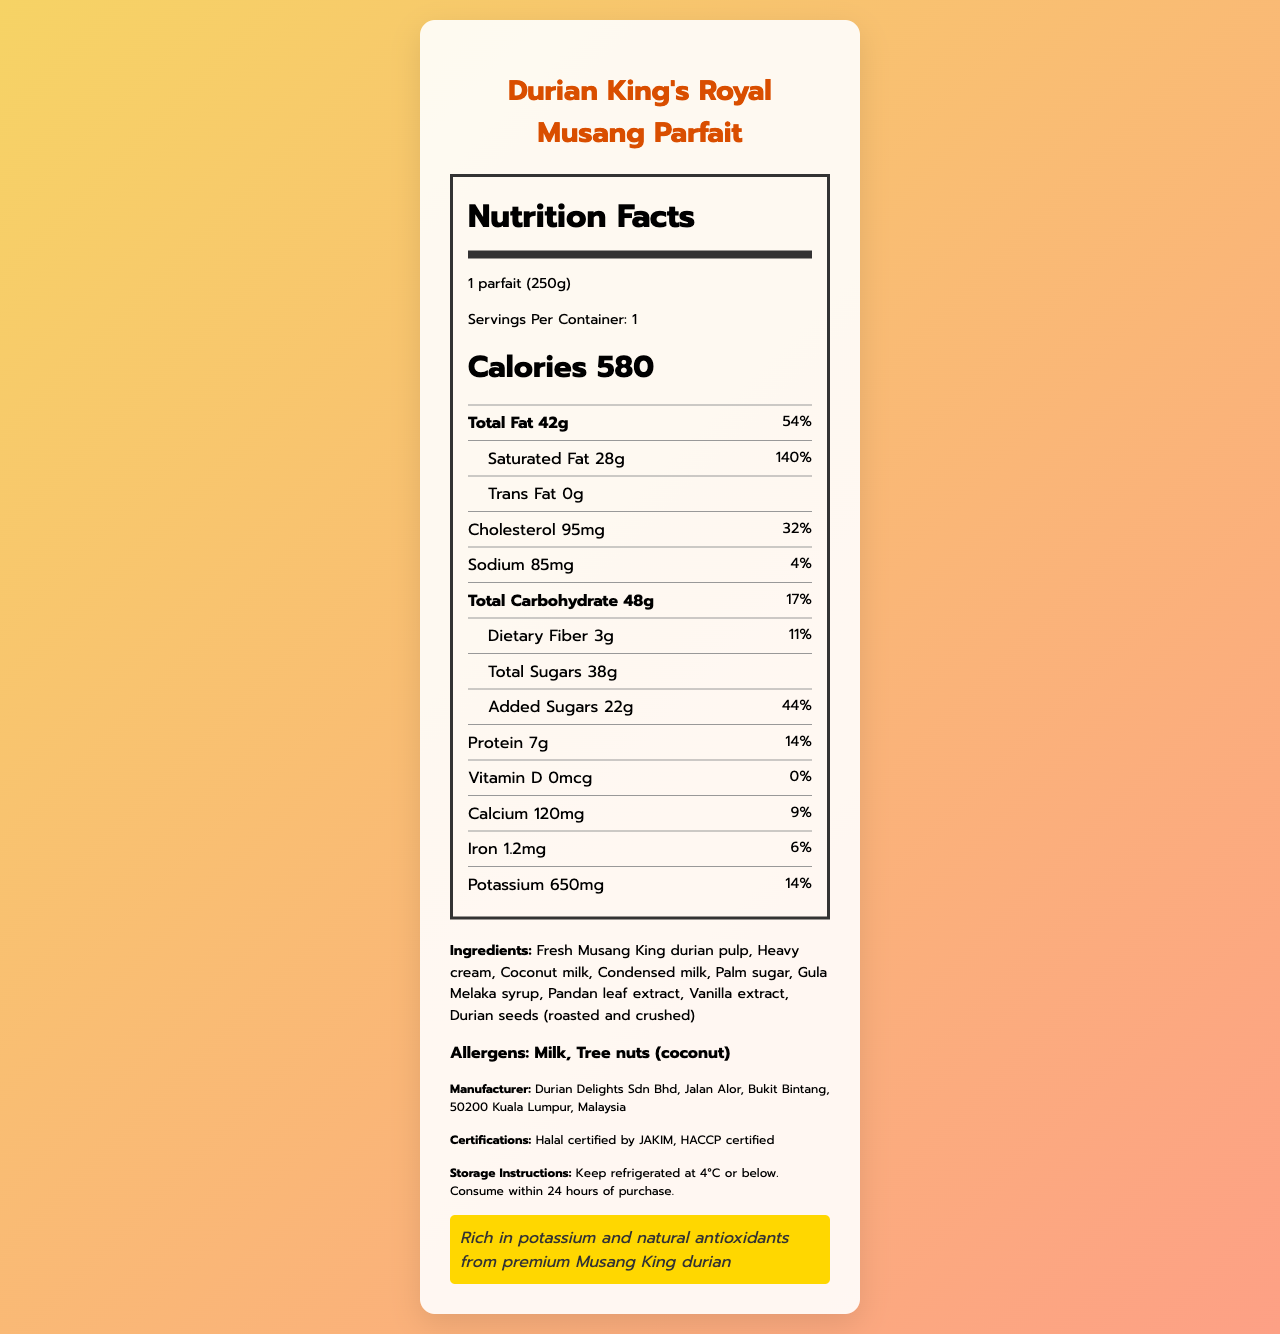what is the serving size of the Durian King's Royal Musang Parfait? The serving size is specified as "1 parfait (250g)" under the serving information section.
Answer: 1 parfait (250g) how many calories are in one serving? The calories per serving are listed as 580 in the calories section.
Answer: 580 calories what is the total fat content per serving, and what percentage of the daily value does it represent? The total fat content is 42g and it represents 54% of the daily value, both listed next to the "Total Fat" label.
Answer: 42g, 54% what are the ingredients of the dessert? The ingredients are listed in the ingredients section of the document.
Answer: Fresh Musang King durian pulp, Heavy cream, Coconut milk, Condensed milk, Palm sugar, Gula Melaka syrup, Pandan leaf extract, Vanilla extract, Durian seeds (roasted and crushed) are there any allergens in the Durian King’s Royal Musang Parfait? The allergens listed are "Milk" and "Tree nuts (coconut)" in the allergens section.
Answer: Yes which of the following nutritional contents are marked with the highest daily value percentage? A. Saturated Fat B. Cholesterol C. Sodium D. Total Carbohydrate Saturated Fat has the highest daily value percentage at 140%.
Answer: A. Saturated Fat how much added sugar is in one serving of the parfait? Added Sugars are listed as 22g and represent 44% of the daily value.
Answer: 22g is the product halal-certified? The document states that it is Halal certified by JAKIM.
Answer: Yes how long should the Durian King's Royal Musang Parfait be consumed within after purchase? The storage instructions state that it should be consumed within 24 hours of purchase.
Answer: 24 hours what kind of nutritional claim does the Durian King's Royal Musang Parfait make? The nutritional claim section states this about the product.
Answer: Rich in potassium and natural antioxidants from premium Musang King durian does the parfait contain any Vitamin D? The Vitamin D amount is listed as 0 mcg, with 0% of the daily value.
Answer: No where is the manufacturer located? The manufacturer information section provides the address.
Answer: Jalan Alor, Bukit Bintang, 50200 Kuala Lumpur, Malaysia which nutrient is present in the highest amount compared to the others? A. Calcium B. Iron C. Potassium D. Dietary Fiber Potassium is present in the highest amount at 650 mg, compared to Calcium (120 mg), Iron (1.2 mg), and Dietary Fiber (3g).
Answer: C. Potassium how much cholesterol does one serving of the parfait contain? The cholesterol content is listed as 95 mg with a daily value percentage of 32%.
Answer: 95 mg what is the main idea of the document? The document includes the product name, serving size, calories, nutritional content, ingredients, allergens, manufacturer information, certifications, storage instructions, and a nutritional claim, summarized in a formatted nutrition facts label style.
Answer: The main idea of the document is to provide detailed nutrition information and ingredients of the premium Malaysian durian dessert, Durian King’s Royal Musang Parfait, highlighting its high calorie and fat content, storage instructions, allergens, and certifications. how much dietary fiber does the dessert contain? The dietary fiber content is listed as 3g with a daily value percentage of 11%.
Answer: 3g did the dessert receive any certifications? The document states it is Halal certified by JAKIM and HACCP certified.
Answer: Yes is it possible to determine the taste of the dessert from the information provided? The document provides nutritional information, ingredients, and other factual information but does not describe the taste of the dessert.
Answer: Cannot be determined 